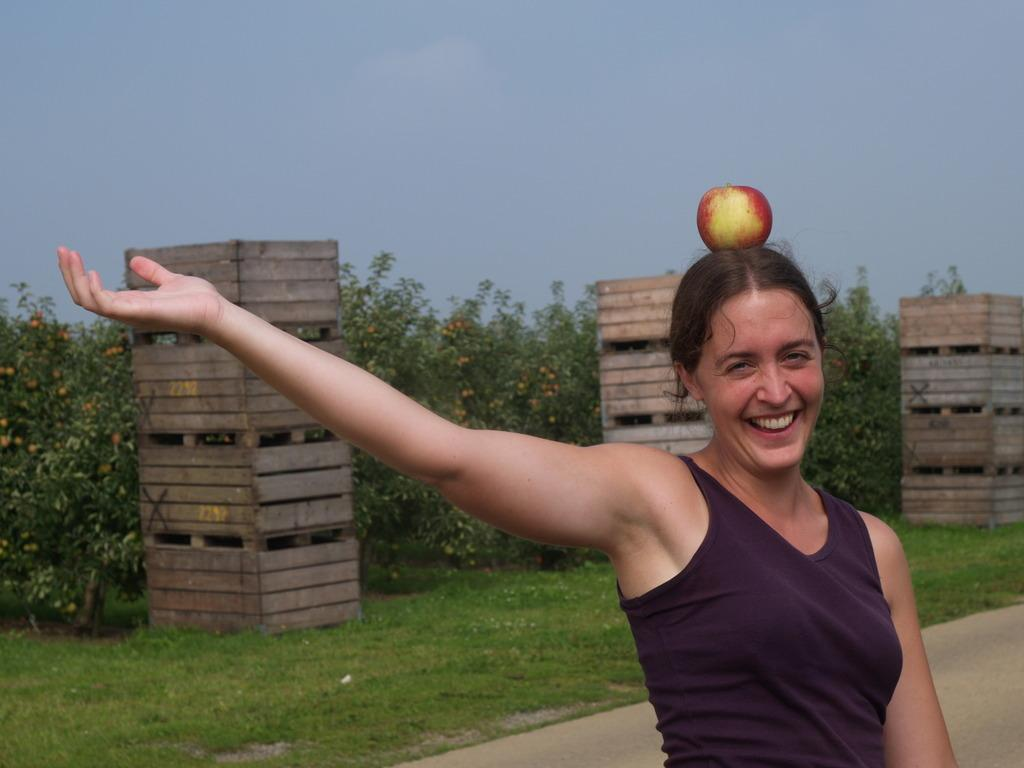What is the woman in the image doing? The woman is standing in the image and smiling. What is on the woman's head in the image? There is a red apple on the woman's head. What can be seen in the background of the image? There are wooden pillars and trees visible in the image. What type of fuel is being used by the woman in the image? There is no indication in the image that the woman is using any type of fuel. What question is the woman asking in the image? The image does not show the woman asking any questions. 